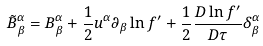Convert formula to latex. <formula><loc_0><loc_0><loc_500><loc_500>\tilde { B } ^ { \alpha } _ { \beta } = B ^ { \alpha } _ { \beta } + \frac { 1 } { 2 } u ^ { \alpha } \partial _ { \beta } \ln f ^ { \prime } + \frac { 1 } { 2 } \frac { D \ln f ^ { \prime } } { D \tau } \delta ^ { \alpha } _ { \beta }</formula> 